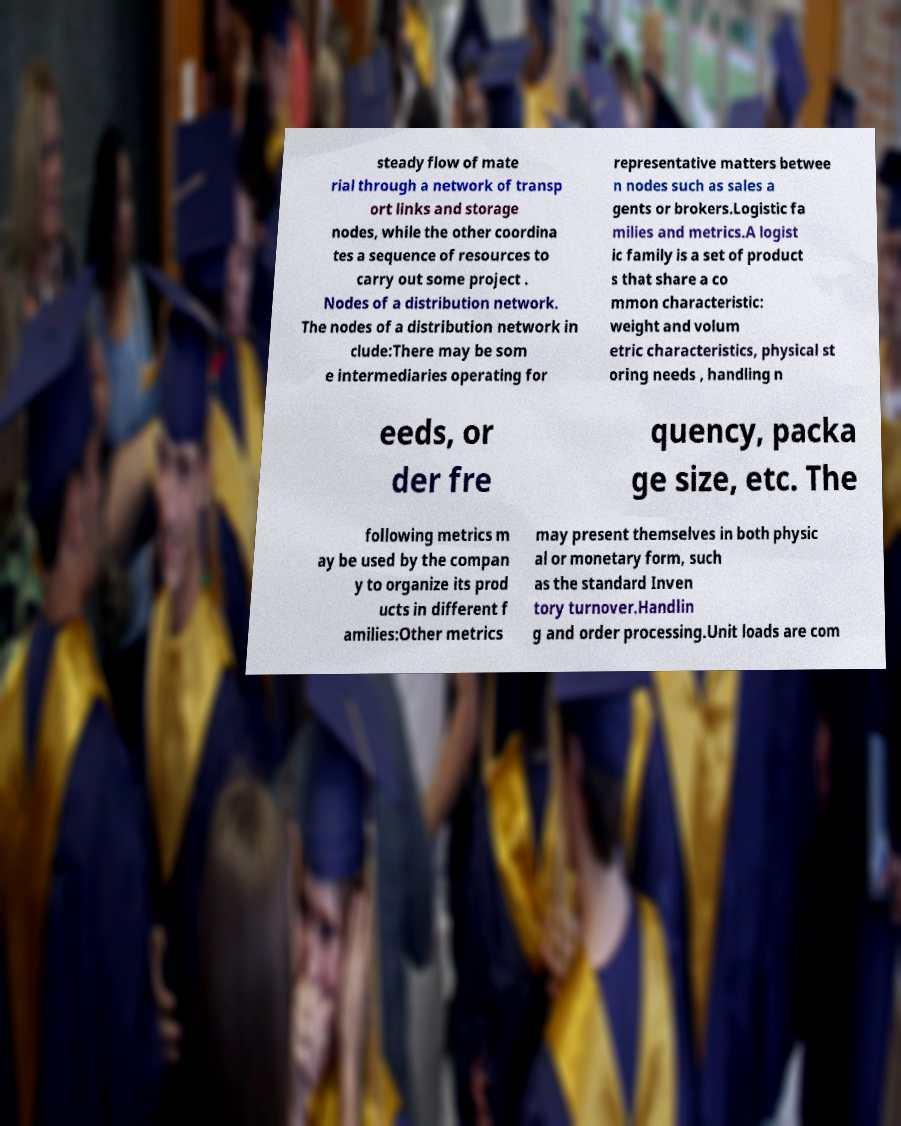What messages or text are displayed in this image? I need them in a readable, typed format. steady flow of mate rial through a network of transp ort links and storage nodes, while the other coordina tes a sequence of resources to carry out some project . Nodes of a distribution network. The nodes of a distribution network in clude:There may be som e intermediaries operating for representative matters betwee n nodes such as sales a gents or brokers.Logistic fa milies and metrics.A logist ic family is a set of product s that share a co mmon characteristic: weight and volum etric characteristics, physical st oring needs , handling n eeds, or der fre quency, packa ge size, etc. The following metrics m ay be used by the compan y to organize its prod ucts in different f amilies:Other metrics may present themselves in both physic al or monetary form, such as the standard Inven tory turnover.Handlin g and order processing.Unit loads are com 